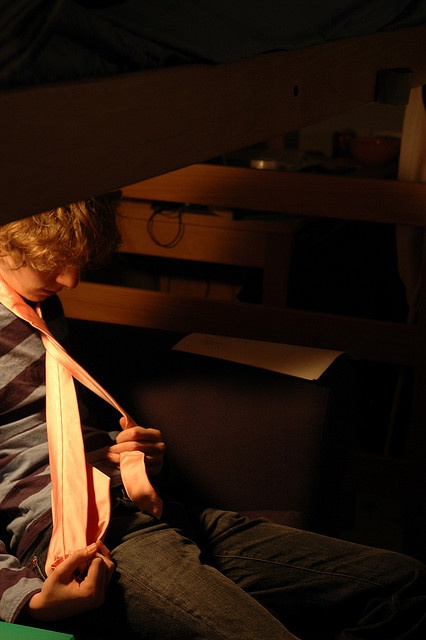Describe the objects in this image and their specific colors. I can see people in black, maroon, orange, and khaki tones, couch in black, maroon, and brown tones, tie in black, orange, khaki, and tan tones, bowl in black tones, and cup in black tones in this image. 